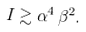<formula> <loc_0><loc_0><loc_500><loc_500>I \gtrsim \alpha ^ { 4 } \, \beta ^ { 2 } .</formula> 